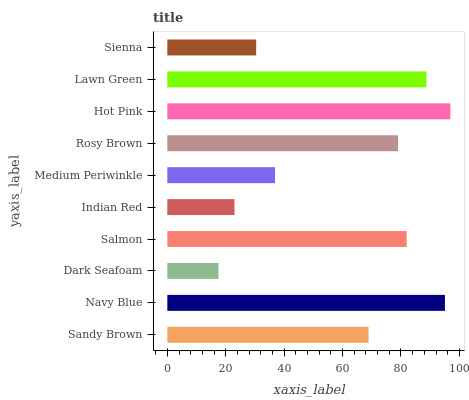Is Dark Seafoam the minimum?
Answer yes or no. Yes. Is Hot Pink the maximum?
Answer yes or no. Yes. Is Navy Blue the minimum?
Answer yes or no. No. Is Navy Blue the maximum?
Answer yes or no. No. Is Navy Blue greater than Sandy Brown?
Answer yes or no. Yes. Is Sandy Brown less than Navy Blue?
Answer yes or no. Yes. Is Sandy Brown greater than Navy Blue?
Answer yes or no. No. Is Navy Blue less than Sandy Brown?
Answer yes or no. No. Is Rosy Brown the high median?
Answer yes or no. Yes. Is Sandy Brown the low median?
Answer yes or no. Yes. Is Lawn Green the high median?
Answer yes or no. No. Is Sienna the low median?
Answer yes or no. No. 